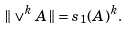Convert formula to latex. <formula><loc_0><loc_0><loc_500><loc_500>\| \vee ^ { k } A \| = s _ { 1 } ( A ) ^ { k } .</formula> 